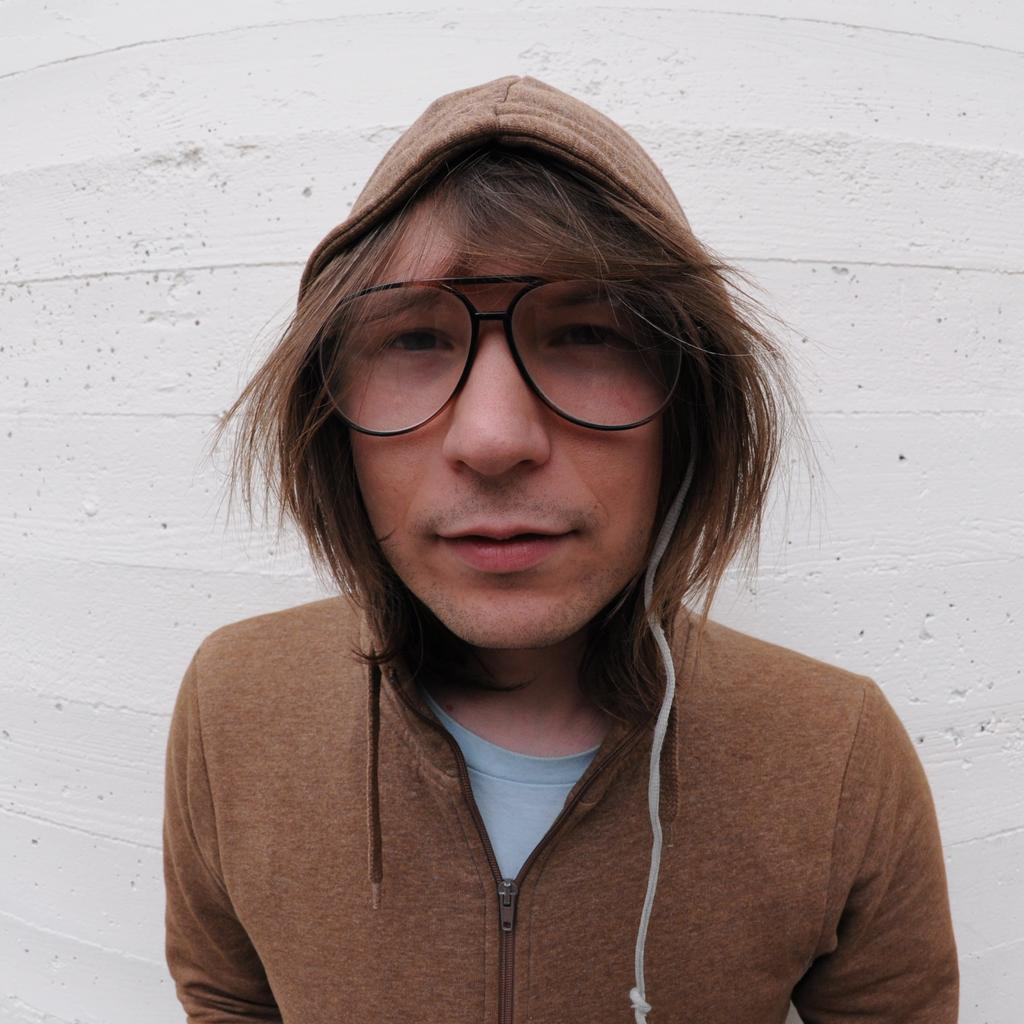Who is present in the image? There is a man in the image. What is the man wearing in the image? The man is wearing spectacles in the image. What is the man's posture in the image? The man is standing in the image. What can be seen in the background of the image? There is a big white wall in the background of the image. What type of cork can be seen in the image? There is no cork present in the image. What is being exchanged between the man and another person in the image? There is no exchange between the man and another person visible in the image. 